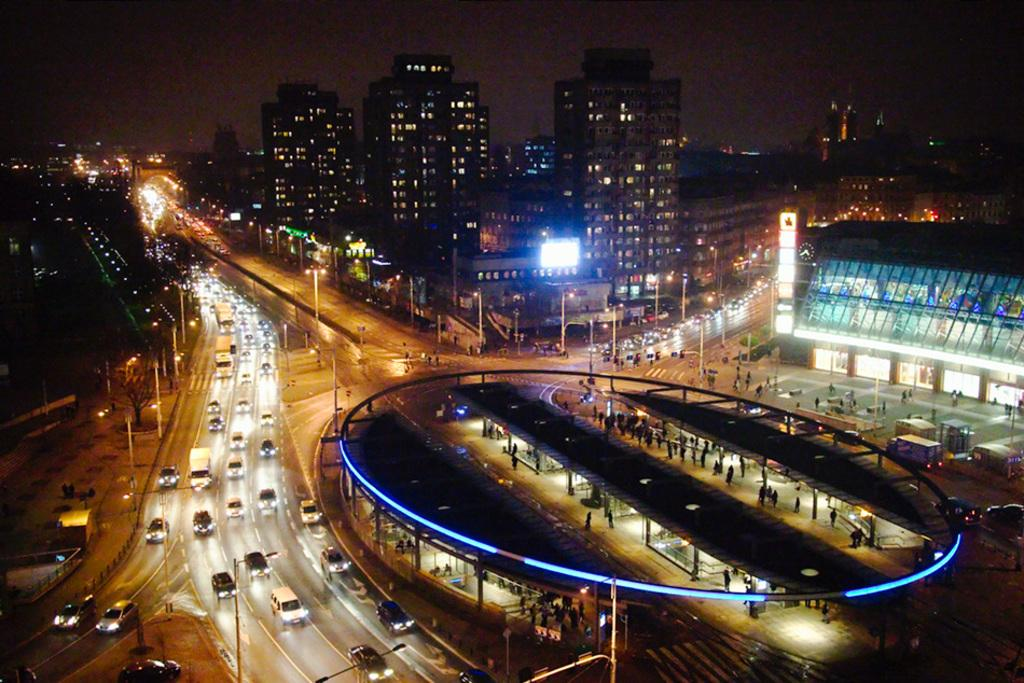What can be seen on the road in the image? There are vehicles on the road in the image. What type of structures can be seen in the image? There are buildings visible in the image. What else is present in the image besides vehicles and buildings? There are lights present in the image. How much money is being exchanged between the vehicles in the image? There is no indication of money being exchanged between the vehicles in the image. What type of stone can be seen in the image? There is no stone present in the image. 